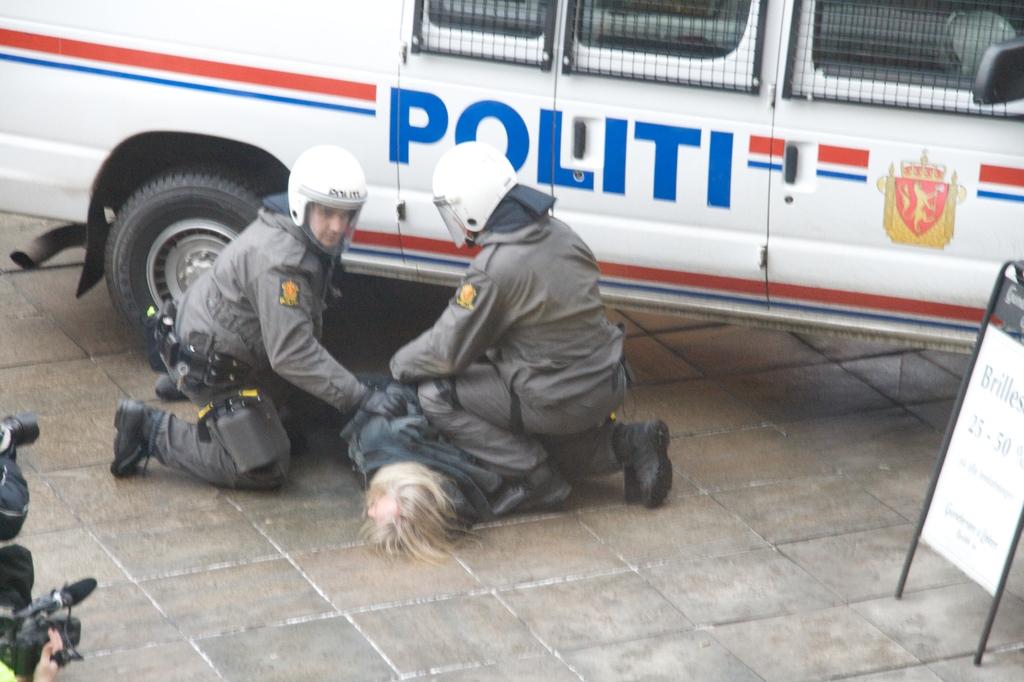What organization do these men work for?
Your response must be concise. Politi. What two numbers can be seen on the white post on the right?
Give a very brief answer. 25, 50. 